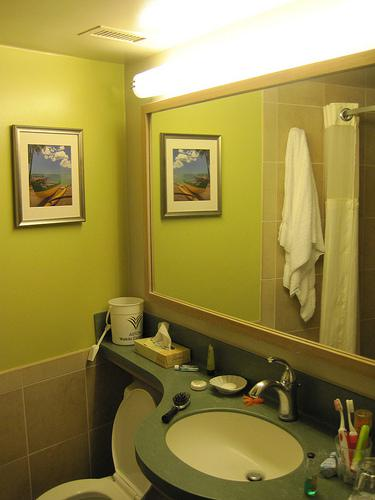Question: how many toothbrushes are there?
Choices:
A. Three.
B. Two.
C. Four.
D. One.
Answer with the letter. Answer: B Question: what is to the left of the sink?
Choices:
A. Shaving razor.
B. Hair gel.
C. Hairbrush.
D. Deodorant.
Answer with the letter. Answer: C 